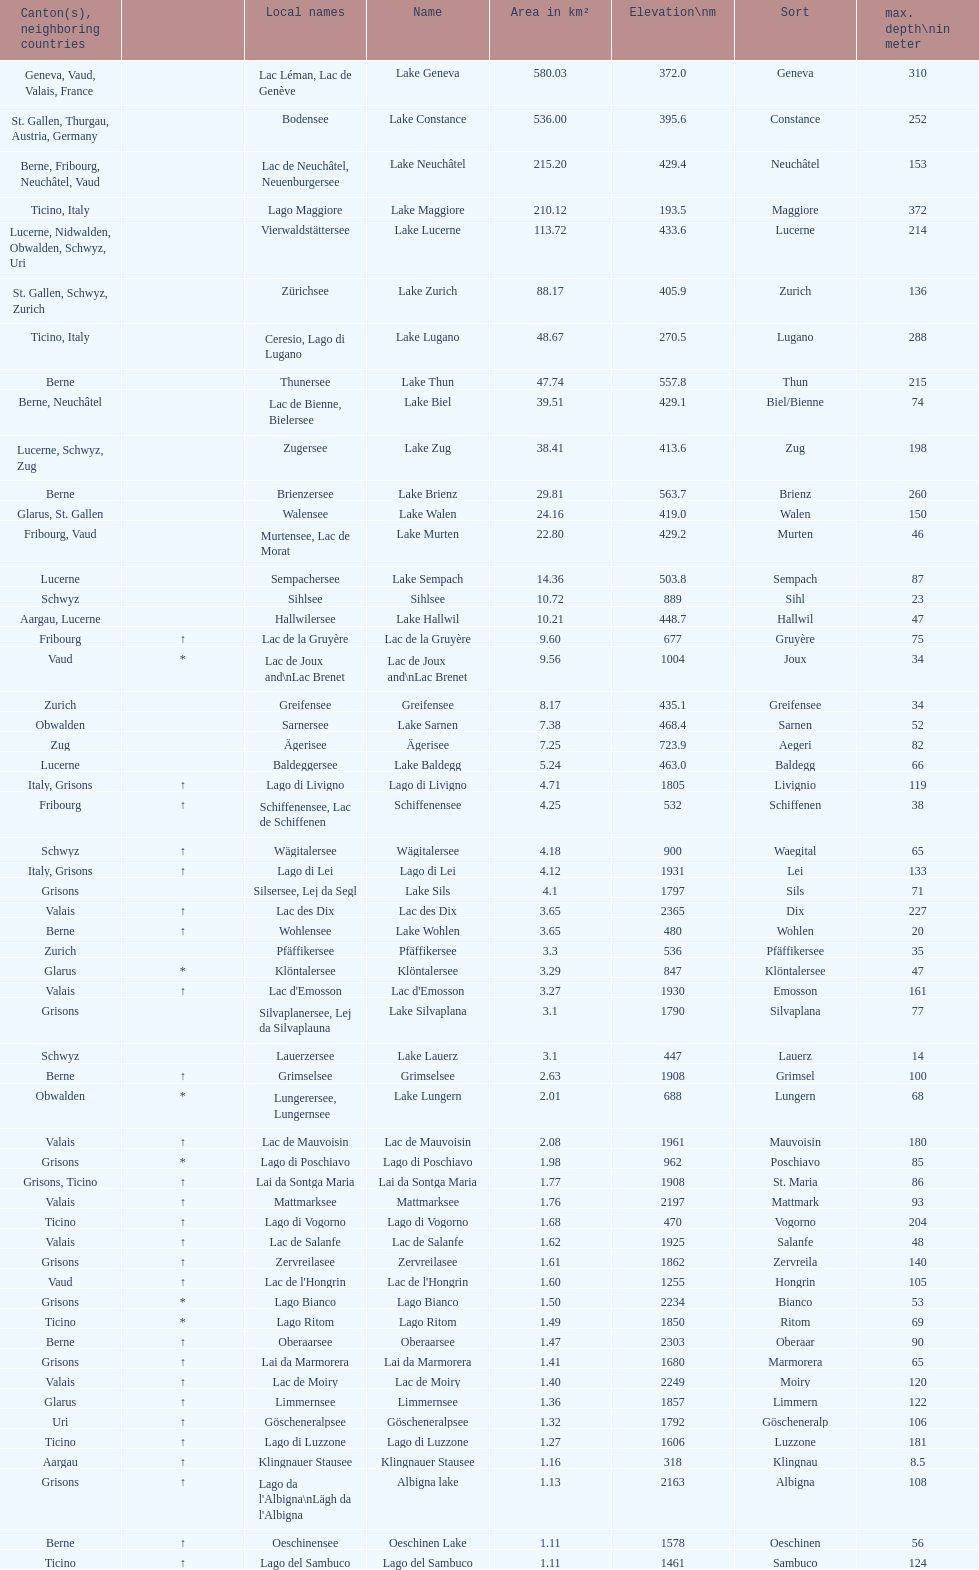Which lake has the largest elevation? Lac des Dix. 